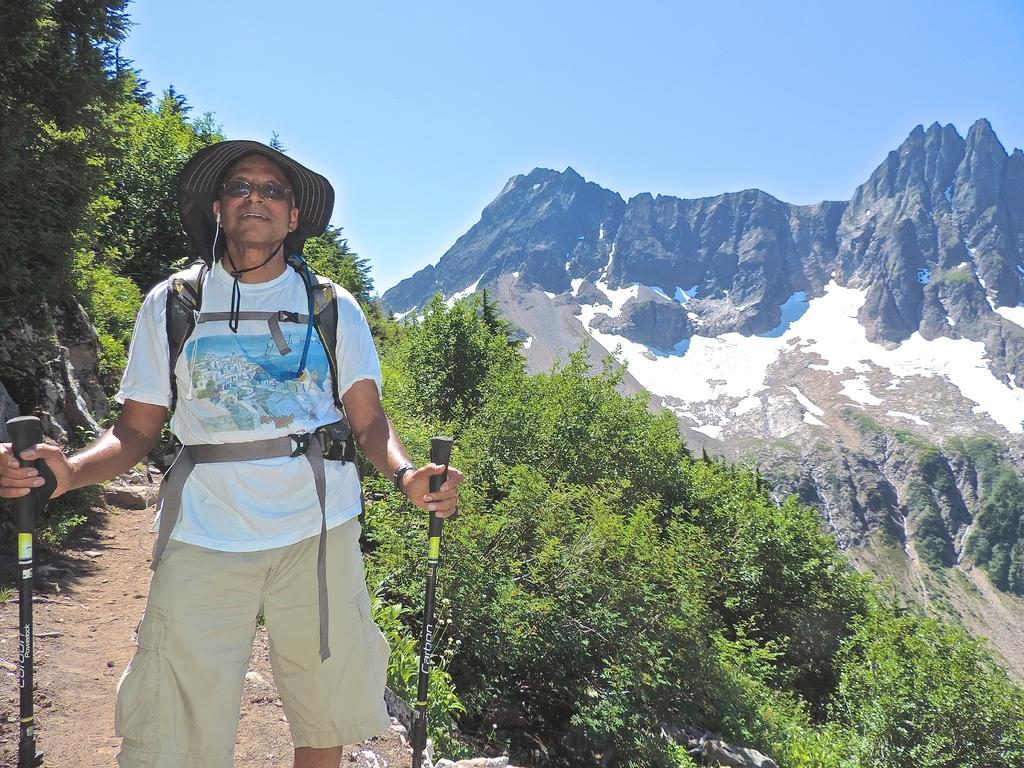What is the person in the image wearing? The person is wearing trekking equipment in the image. What is the person doing in the image? The person is standing in the image. What can be seen in the background of the image? Beautiful scenic places, mountains, and trees are visible in the background of the image. What type of flower is the ghost holding in the image? There is no flower or ghost present in the image. 